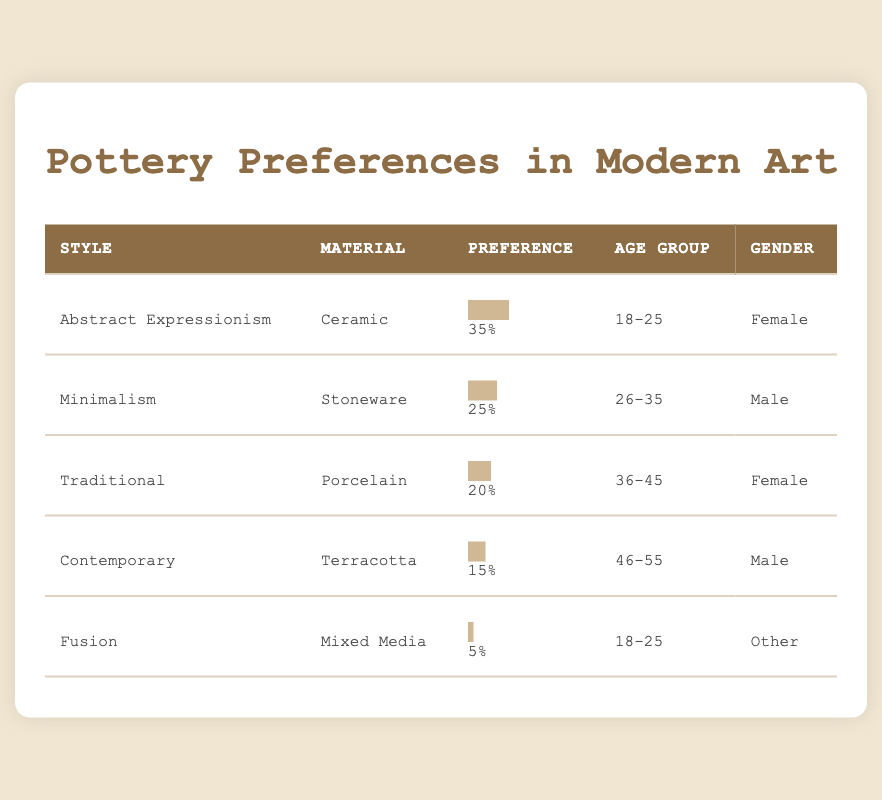What style has the highest preference percentage? The highest preference percentage in the table is for "Abstract Expressionism," which has a preference percentage of 35.
Answer: Abstract Expressionism What is the preferred material for the "Traditional" pottery style? According to the table, the preferred material for the "Traditional" pottery style is "Porcelain."
Answer: Porcelain How many styles have a preference percentage of 20 or lower? The styles that have a preference percentage of 20 or lower are "Traditional" (20%), "Contemporary" (15%), and "Fusion" (5%). Thus, there are 3 styles that fit this criterion.
Answer: 3 Is there a style that is preferred equally by both genders? According to the table, all styles listed are preferred by different genders, with no style having the same gender preference. Therefore, the answer is false.
Answer: No What is the average preference percentage of the pottery styles for the age group 18-25? The age group 18-25 includes "Abstract Expressionism" (35%) and "Fusion" (5%). To find the average, we add them: 35 + 5 = 40, and then divide by 2, giving us an average of 20.
Answer: 20 What is the total preference percentage of all pottery styles in the table? To find the total preference percentage, we sum up all the values: 35 + 25 + 20 + 15 + 5 = 100. Therefore, the total preference percentage is 100.
Answer: 100 How does the preference for "Terracotta" compare to "Stoneware"? The preference percentage for "Terracotta" is 15, while the preference for "Stoneware" is 25. This shows that "Stoneware" is preferred more than "Terracotta" by 10 percentage points.
Answer: Stoneware is preferred more Which gender showed a preference for the "Contemporary" pottery style? The table indicates that the "Contemporary" pottery style is preferred by the male gender.
Answer: Male Based on the survey, is there a pottery style that was preferred by an age group older than 45? The table shows that all listed styles have age groups of 55 or younger, and none exceed this age. Hence, the answer is false.
Answer: No 